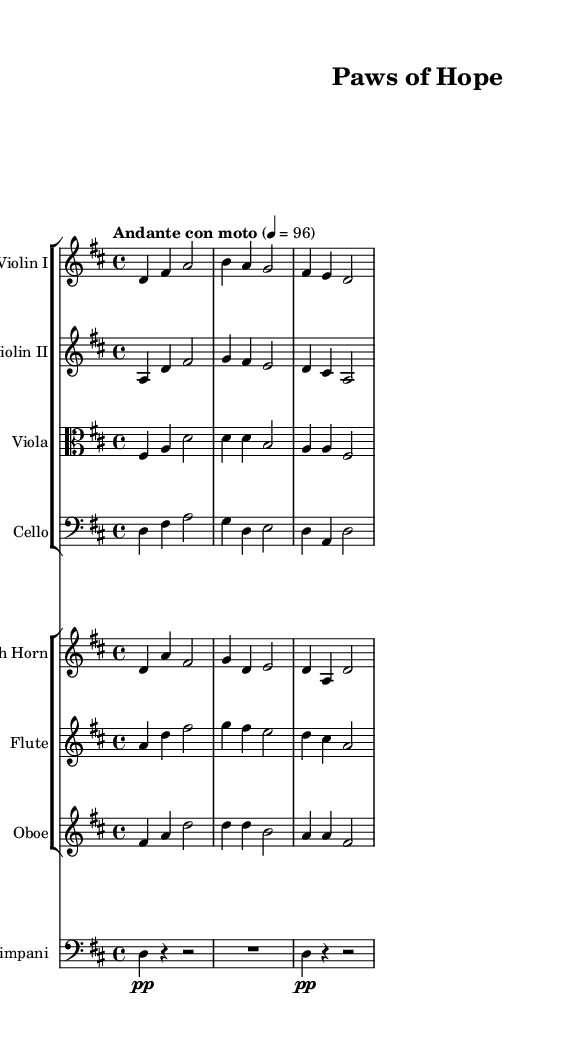What is the key signature of this music? The key signature indicated is D major, which has two sharps (F# and C#). This can be deduced from the key signature markings found at the beginning of the staff.
Answer: D major What is the time signature of this piece? The time signature is 4/4, which is shown as a fraction at the beginning of the score. This means there are four beats in each measure with the quarter note receiving one beat.
Answer: 4/4 What is the tempo marking of the piece? The tempo marking reads "Andante con moto," which indicates a moderate pace. This is specified near the beginning of the score and dictates the overall speed of the piece.
Answer: Andante con moto How many measures are present in this excerpt? By counting the number of distinct vertical lines (bar lines) on the staff, we can identify the number of measures. Each vertical line typically represents the end of a measure. In this case, there are 6 measures in the provided music.
Answer: 6 Which instruments are included in the orchestration? The orchestration consists of Violin I, Violin II, Viola, Cello, French Horn, Flute, Oboe, and Timpani. By looking at the instruments listed at the beginning of each staff, we can easily identify the full set of instruments used.
Answer: Violin I, Violin II, Viola, Cello, French Horn, Flute, Oboe, Timpani What is the dynamics marking for the Timpani? The dynamics marking for the Timpani is "pp," which indicates that it should be played very softly. This is specified directly within the Timpani's staff and influences the playing style.
Answer: pp 